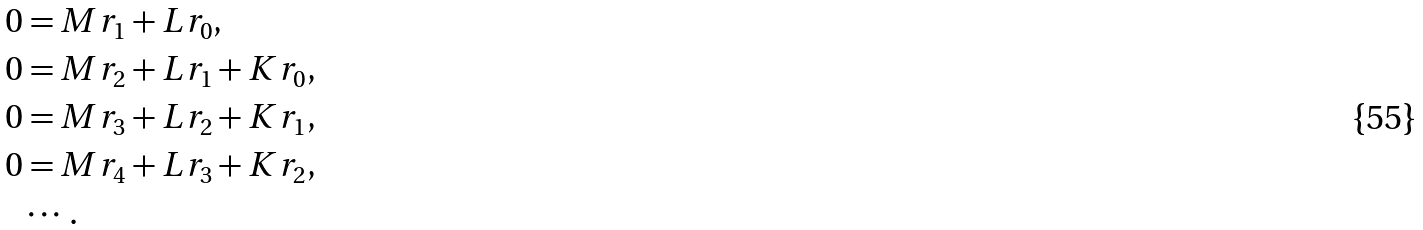<formula> <loc_0><loc_0><loc_500><loc_500>0 & = M r _ { 1 } + L r _ { 0 } , \\ 0 & = M r _ { 2 } + L r _ { 1 } + K r _ { 0 } , \\ 0 & = M r _ { 3 } + L r _ { 2 } + K r _ { 1 } , \\ 0 & = M r _ { 4 } + L r _ { 3 } + K r _ { 2 } , \\ & \cdots .</formula> 